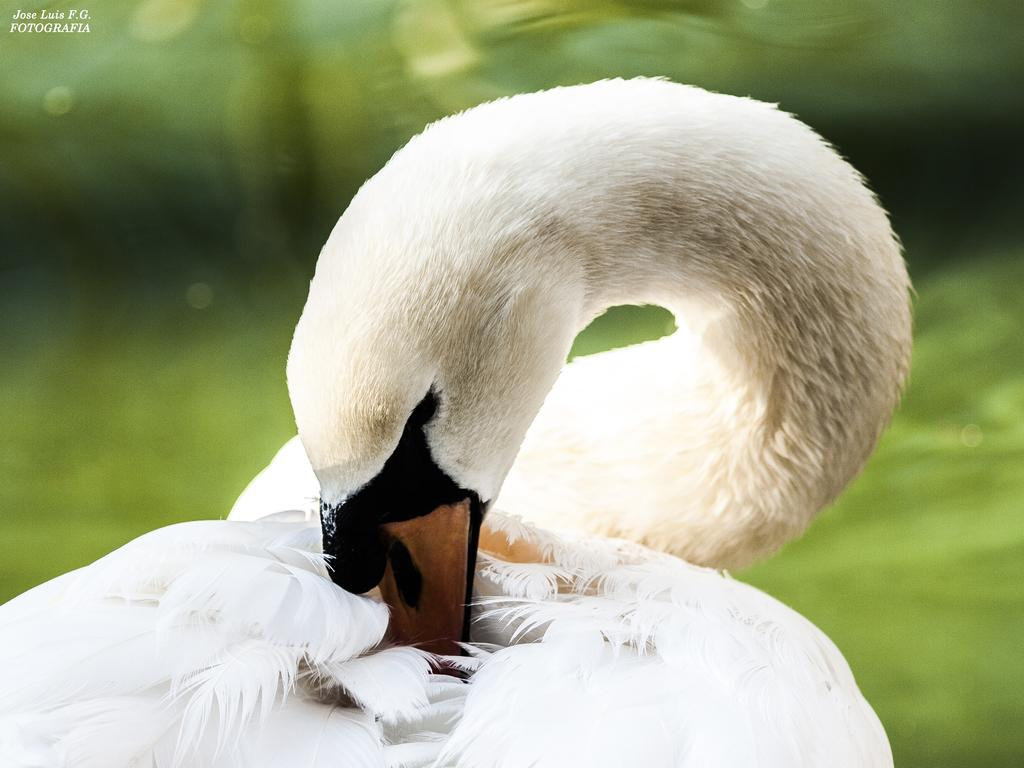What type of animal is in the image? There is a white color bird in the image. Can you describe the background of the image? The background of the image is blurred. Is there any additional information or markings in the image? Yes, there is a watermark in the top left corner of the image. What type of fish can be seen swimming in the image? There is no fish present in the image; it features a white color bird. Can you describe the truck that is visible in the image? There is no truck present in the image. 